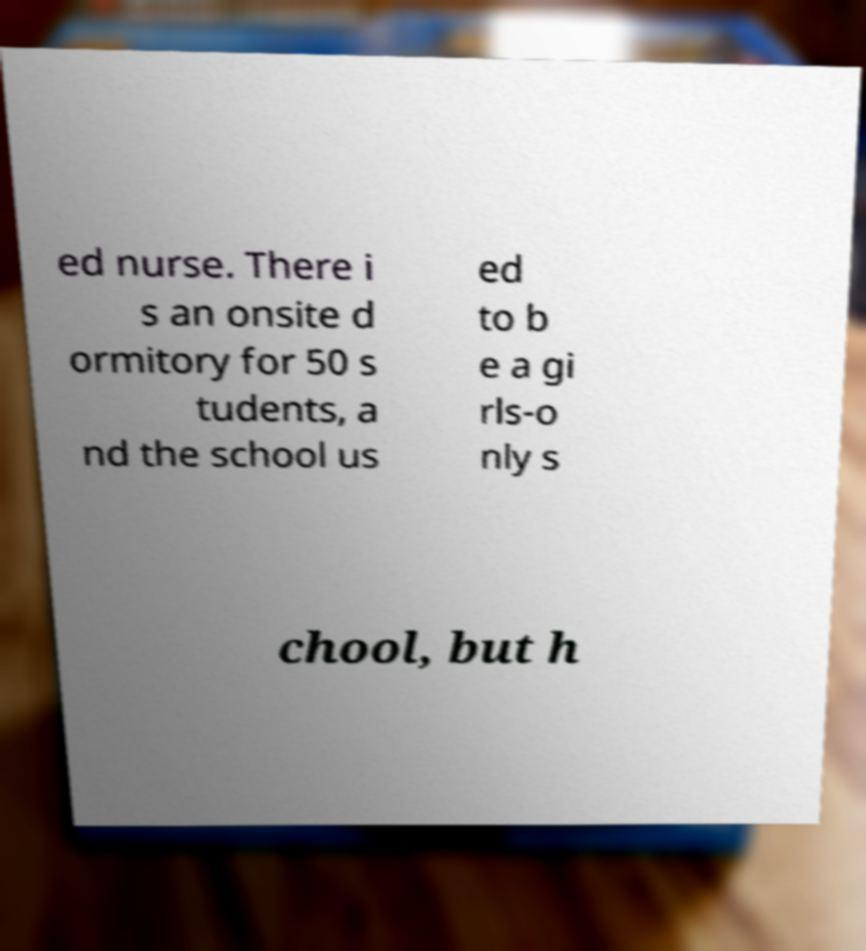There's text embedded in this image that I need extracted. Can you transcribe it verbatim? ed nurse. There i s an onsite d ormitory for 50 s tudents, a nd the school us ed to b e a gi rls-o nly s chool, but h 